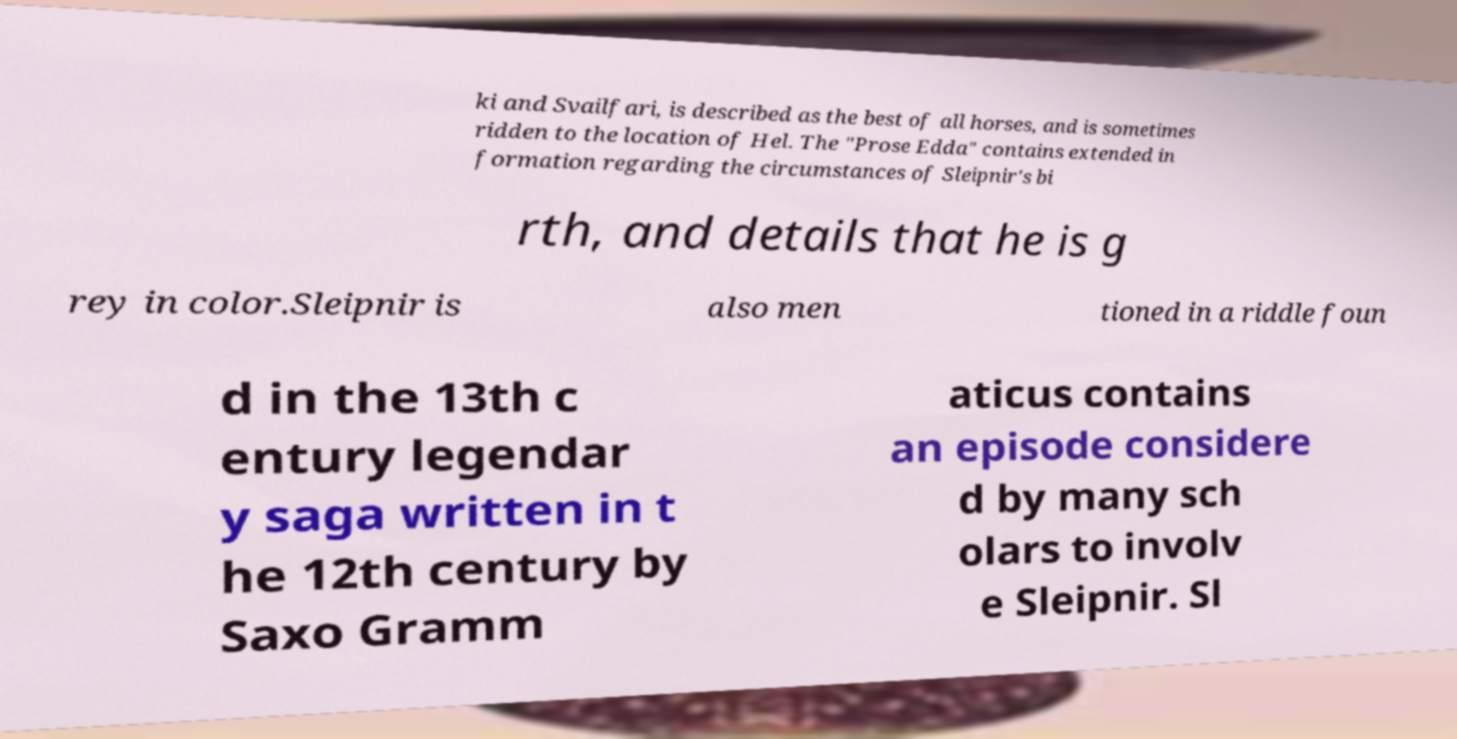Can you read and provide the text displayed in the image?This photo seems to have some interesting text. Can you extract and type it out for me? ki and Svailfari, is described as the best of all horses, and is sometimes ridden to the location of Hel. The "Prose Edda" contains extended in formation regarding the circumstances of Sleipnir's bi rth, and details that he is g rey in color.Sleipnir is also men tioned in a riddle foun d in the 13th c entury legendar y saga written in t he 12th century by Saxo Gramm aticus contains an episode considere d by many sch olars to involv e Sleipnir. Sl 